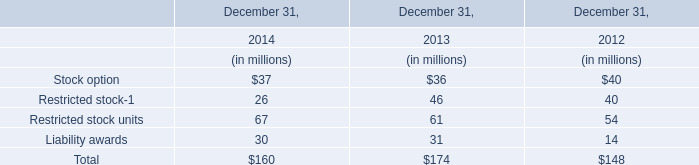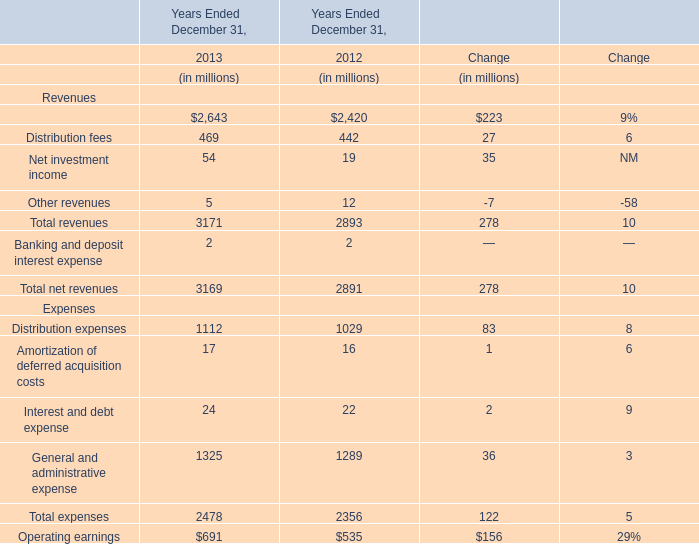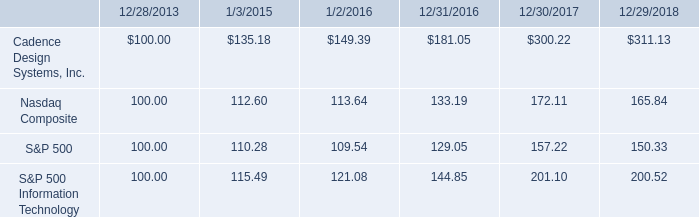What's the total amount of the Total revenues for Revenues in the years where Restricted stock-1 is greater than 30? (in million) 
Computations: (3171 + 2893)
Answer: 6064.0. 